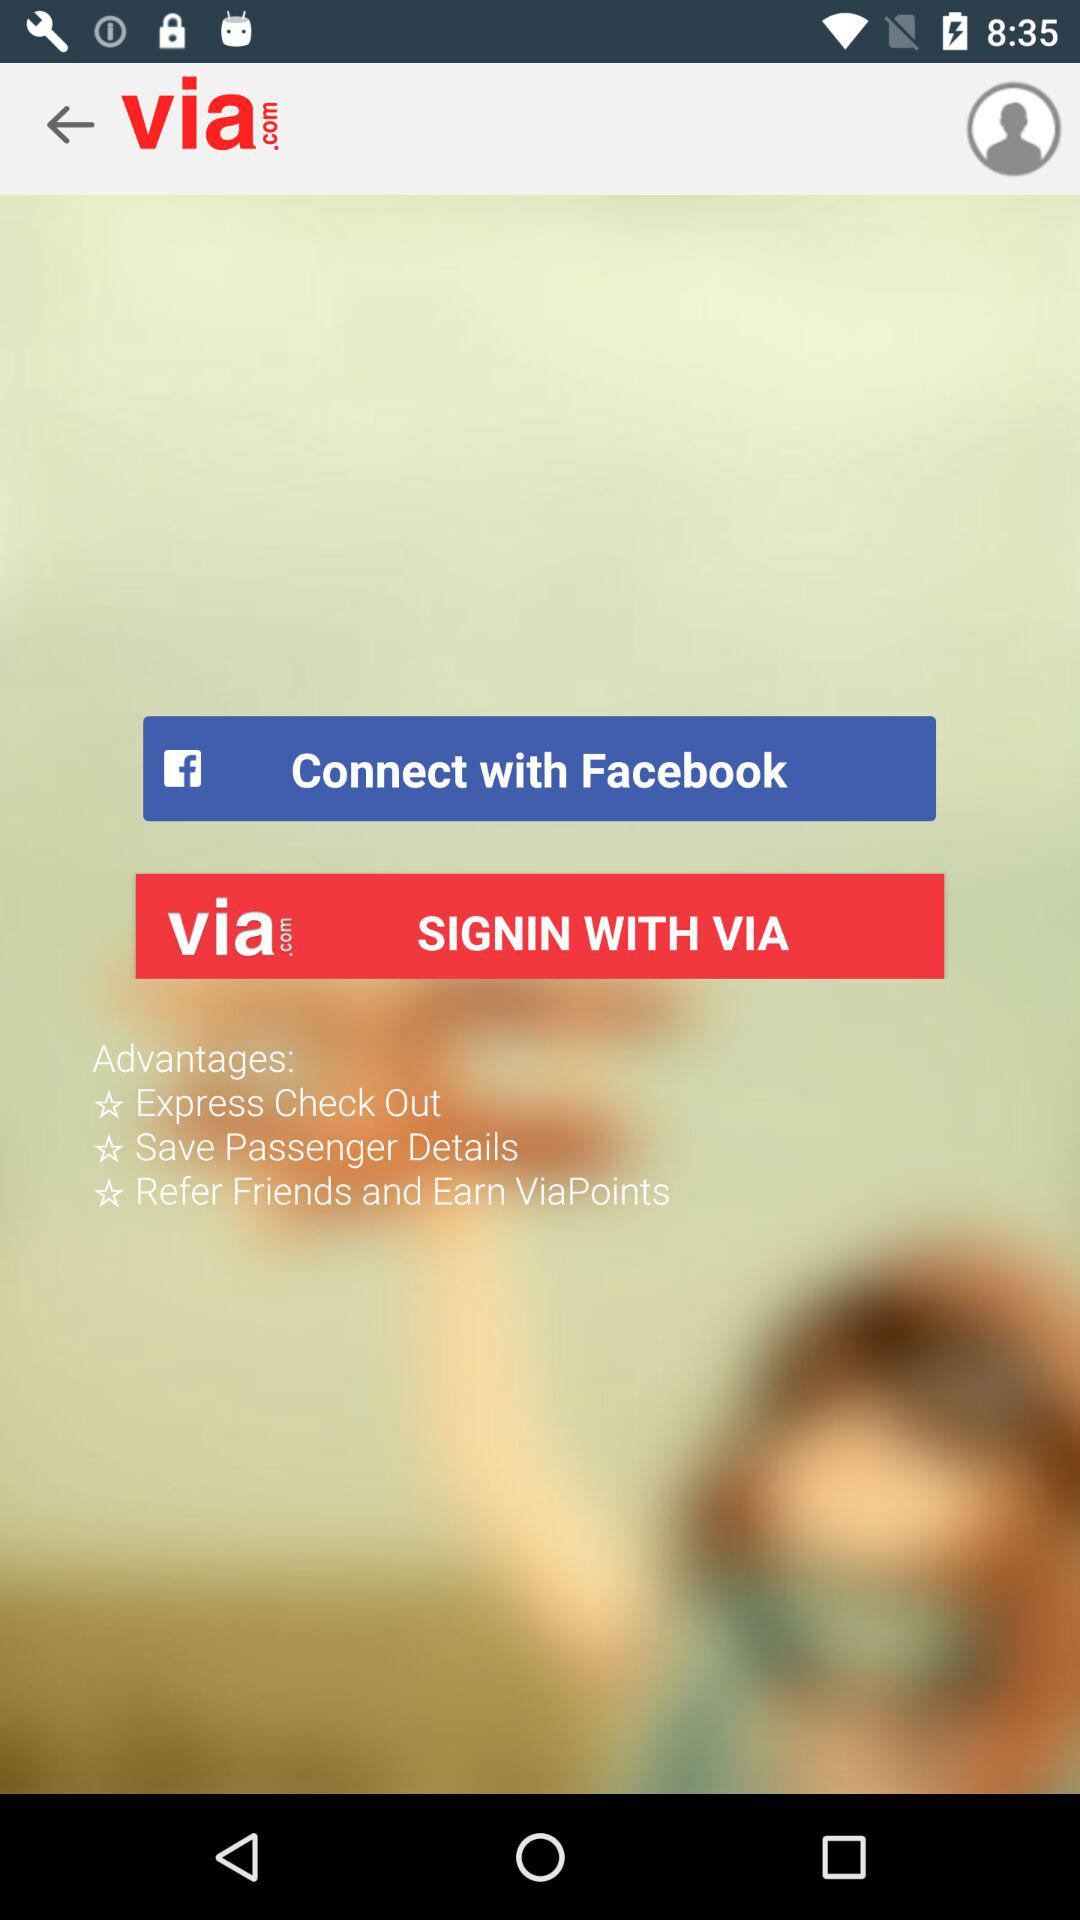What is the application name? The application name is "via.com". 